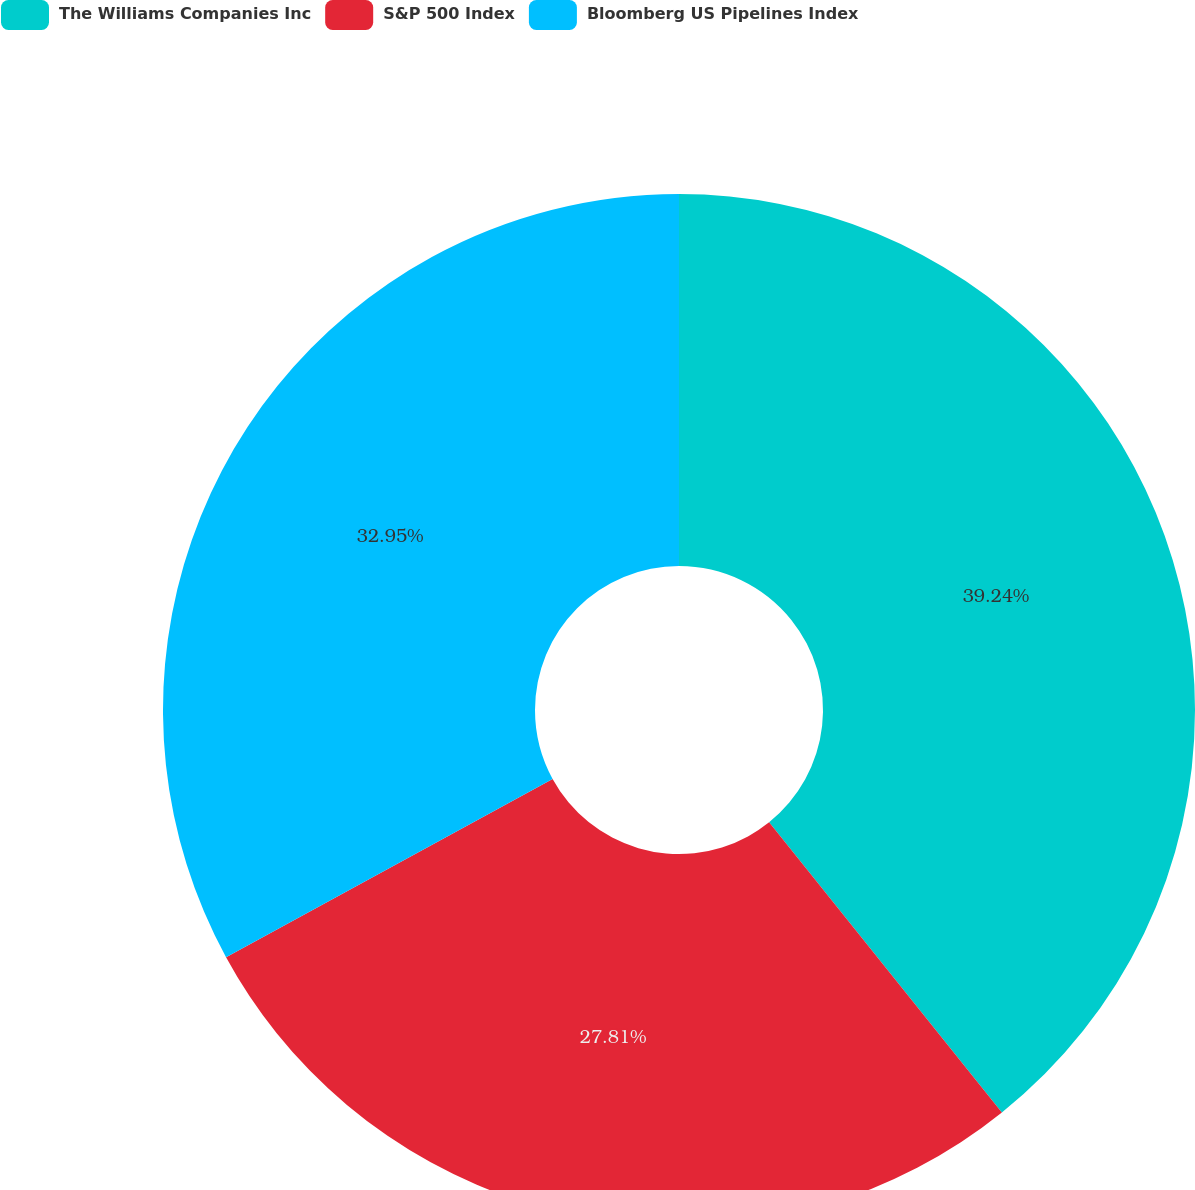<chart> <loc_0><loc_0><loc_500><loc_500><pie_chart><fcel>The Williams Companies Inc<fcel>S&P 500 Index<fcel>Bloomberg US Pipelines Index<nl><fcel>39.24%<fcel>27.81%<fcel>32.95%<nl></chart> 